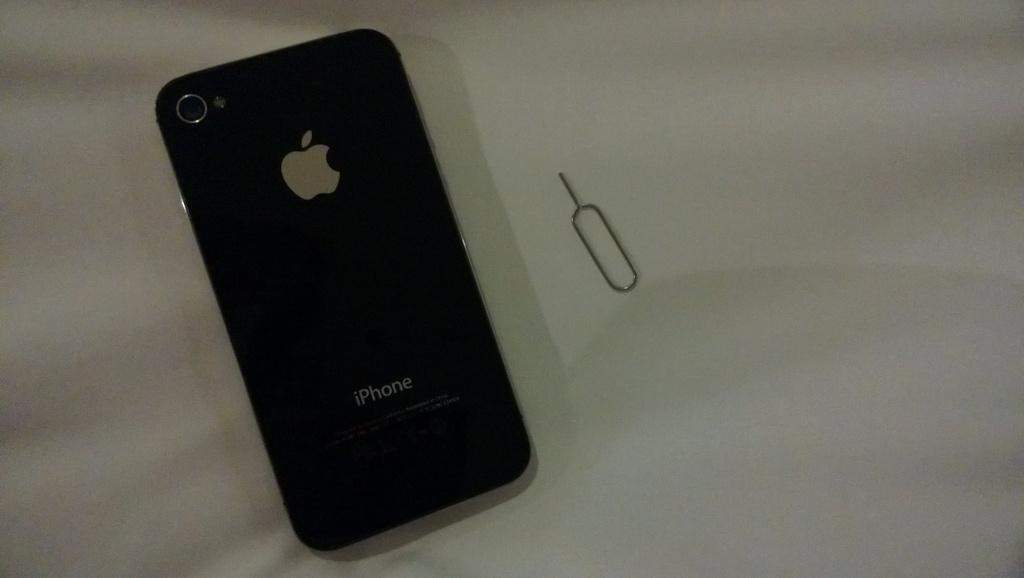Provide a one-sentence caption for the provided image. The Back of an Apple Iphone with the Apple Logo and a Camera. 